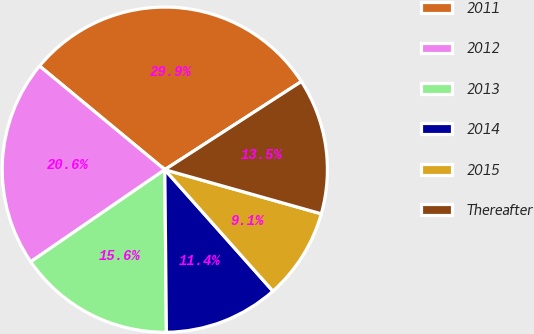<chart> <loc_0><loc_0><loc_500><loc_500><pie_chart><fcel>2011<fcel>2012<fcel>2013<fcel>2014<fcel>2015<fcel>Thereafter<nl><fcel>29.87%<fcel>20.58%<fcel>15.58%<fcel>11.42%<fcel>9.05%<fcel>13.5%<nl></chart> 